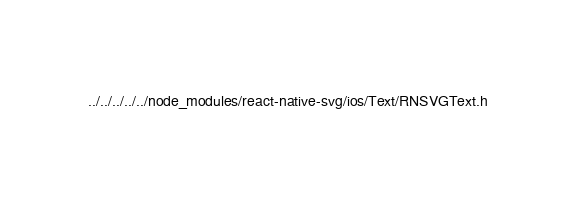Convert code to text. <code><loc_0><loc_0><loc_500><loc_500><_C_>../../../../../node_modules/react-native-svg/ios/Text/RNSVGText.h</code> 